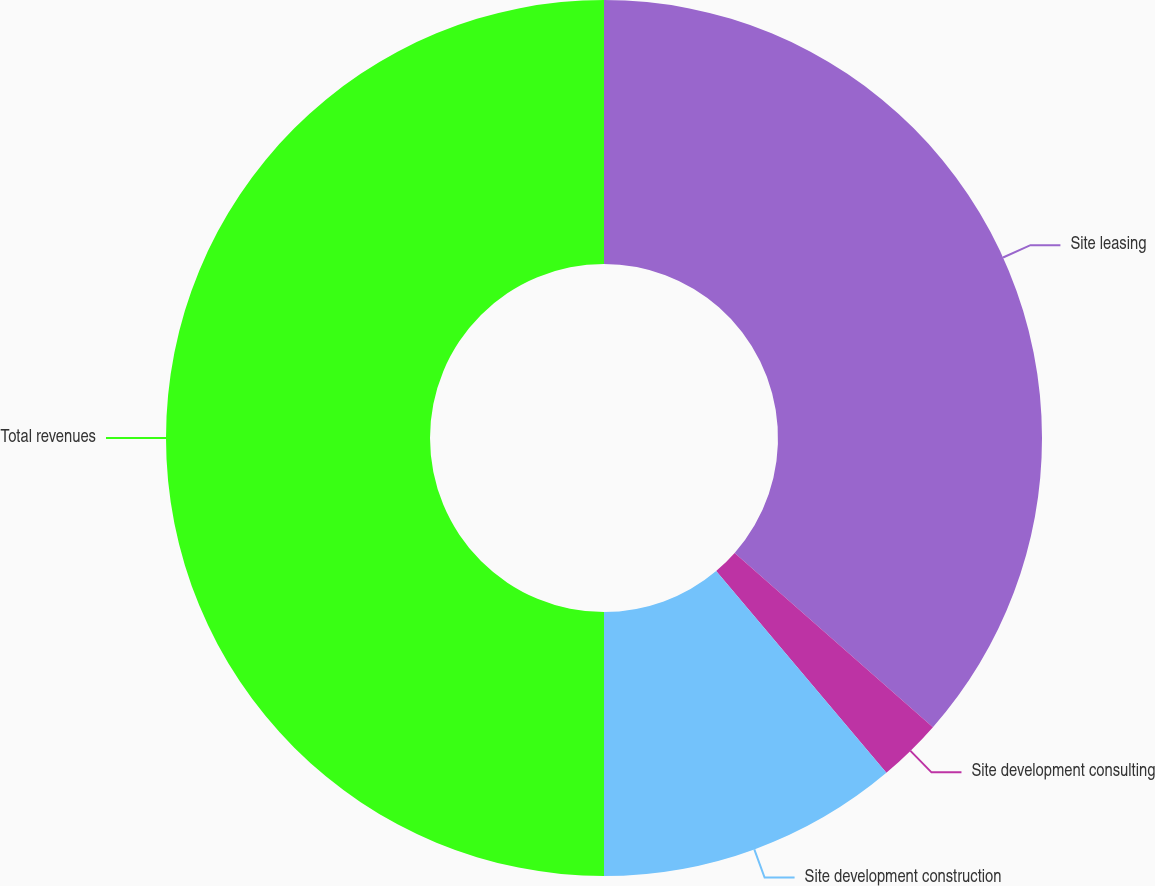<chart> <loc_0><loc_0><loc_500><loc_500><pie_chart><fcel>Site leasing<fcel>Site development consulting<fcel>Site development construction<fcel>Total revenues<nl><fcel>36.48%<fcel>2.37%<fcel>11.15%<fcel>50.0%<nl></chart> 